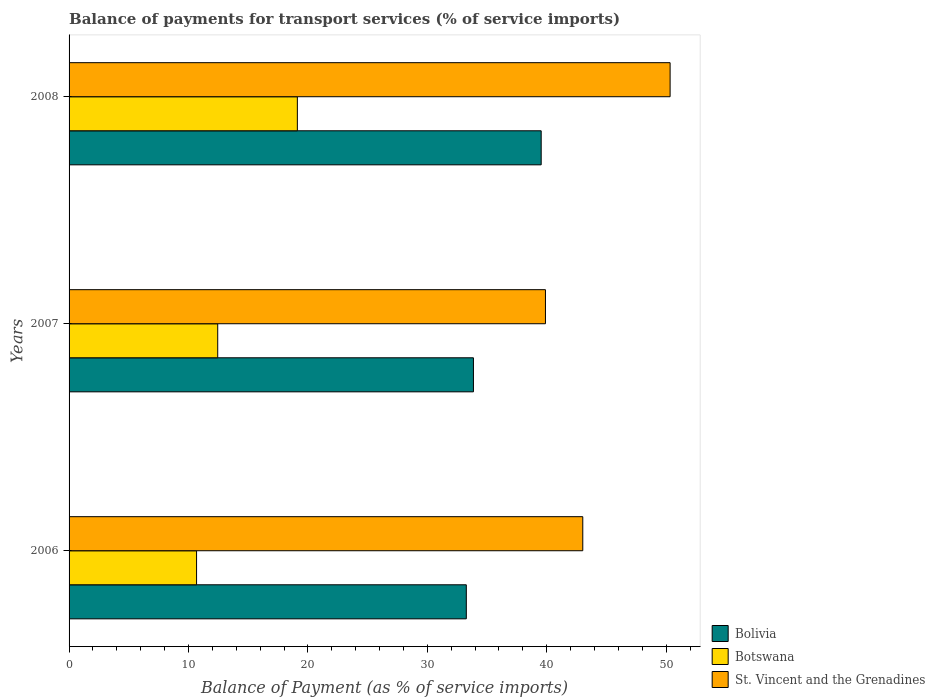How many different coloured bars are there?
Make the answer very short. 3. Are the number of bars on each tick of the Y-axis equal?
Provide a short and direct response. Yes. How many bars are there on the 3rd tick from the bottom?
Your answer should be very brief. 3. What is the label of the 3rd group of bars from the top?
Provide a succinct answer. 2006. In how many cases, is the number of bars for a given year not equal to the number of legend labels?
Ensure brevity in your answer.  0. What is the balance of payments for transport services in St. Vincent and the Grenadines in 2006?
Offer a very short reply. 43.02. Across all years, what is the maximum balance of payments for transport services in St. Vincent and the Grenadines?
Ensure brevity in your answer.  50.33. Across all years, what is the minimum balance of payments for transport services in Botswana?
Keep it short and to the point. 10.68. In which year was the balance of payments for transport services in St. Vincent and the Grenadines minimum?
Keep it short and to the point. 2007. What is the total balance of payments for transport services in Botswana in the graph?
Ensure brevity in your answer.  42.24. What is the difference between the balance of payments for transport services in Botswana in 2007 and that in 2008?
Keep it short and to the point. -6.67. What is the difference between the balance of payments for transport services in Botswana in 2006 and the balance of payments for transport services in St. Vincent and the Grenadines in 2007?
Make the answer very short. -29.21. What is the average balance of payments for transport services in Botswana per year?
Provide a succinct answer. 14.08. In the year 2008, what is the difference between the balance of payments for transport services in Bolivia and balance of payments for transport services in Botswana?
Your response must be concise. 20.42. What is the ratio of the balance of payments for transport services in Botswana in 2007 to that in 2008?
Provide a short and direct response. 0.65. Is the balance of payments for transport services in Botswana in 2007 less than that in 2008?
Offer a terse response. Yes. Is the difference between the balance of payments for transport services in Bolivia in 2006 and 2008 greater than the difference between the balance of payments for transport services in Botswana in 2006 and 2008?
Provide a short and direct response. Yes. What is the difference between the highest and the second highest balance of payments for transport services in Botswana?
Provide a short and direct response. 6.67. What is the difference between the highest and the lowest balance of payments for transport services in Botswana?
Your answer should be very brief. 8.44. Is the sum of the balance of payments for transport services in Bolivia in 2006 and 2008 greater than the maximum balance of payments for transport services in Botswana across all years?
Your answer should be compact. Yes. What does the 3rd bar from the top in 2008 represents?
Make the answer very short. Bolivia. What does the 2nd bar from the bottom in 2007 represents?
Give a very brief answer. Botswana. Is it the case that in every year, the sum of the balance of payments for transport services in Bolivia and balance of payments for transport services in Botswana is greater than the balance of payments for transport services in St. Vincent and the Grenadines?
Give a very brief answer. Yes. Are the values on the major ticks of X-axis written in scientific E-notation?
Provide a succinct answer. No. Where does the legend appear in the graph?
Give a very brief answer. Bottom right. How many legend labels are there?
Your answer should be very brief. 3. What is the title of the graph?
Give a very brief answer. Balance of payments for transport services (% of service imports). Does "Curacao" appear as one of the legend labels in the graph?
Keep it short and to the point. No. What is the label or title of the X-axis?
Make the answer very short. Balance of Payment (as % of service imports). What is the label or title of the Y-axis?
Your response must be concise. Years. What is the Balance of Payment (as % of service imports) in Bolivia in 2006?
Offer a terse response. 33.26. What is the Balance of Payment (as % of service imports) of Botswana in 2006?
Make the answer very short. 10.68. What is the Balance of Payment (as % of service imports) in St. Vincent and the Grenadines in 2006?
Your answer should be compact. 43.02. What is the Balance of Payment (as % of service imports) of Bolivia in 2007?
Your response must be concise. 33.86. What is the Balance of Payment (as % of service imports) in Botswana in 2007?
Keep it short and to the point. 12.45. What is the Balance of Payment (as % of service imports) in St. Vincent and the Grenadines in 2007?
Offer a terse response. 39.89. What is the Balance of Payment (as % of service imports) in Bolivia in 2008?
Give a very brief answer. 39.53. What is the Balance of Payment (as % of service imports) in Botswana in 2008?
Your answer should be compact. 19.12. What is the Balance of Payment (as % of service imports) in St. Vincent and the Grenadines in 2008?
Ensure brevity in your answer.  50.33. Across all years, what is the maximum Balance of Payment (as % of service imports) of Bolivia?
Ensure brevity in your answer.  39.53. Across all years, what is the maximum Balance of Payment (as % of service imports) of Botswana?
Give a very brief answer. 19.12. Across all years, what is the maximum Balance of Payment (as % of service imports) of St. Vincent and the Grenadines?
Provide a short and direct response. 50.33. Across all years, what is the minimum Balance of Payment (as % of service imports) in Bolivia?
Provide a succinct answer. 33.26. Across all years, what is the minimum Balance of Payment (as % of service imports) of Botswana?
Ensure brevity in your answer.  10.68. Across all years, what is the minimum Balance of Payment (as % of service imports) of St. Vincent and the Grenadines?
Offer a terse response. 39.89. What is the total Balance of Payment (as % of service imports) in Bolivia in the graph?
Keep it short and to the point. 106.66. What is the total Balance of Payment (as % of service imports) of Botswana in the graph?
Your answer should be very brief. 42.24. What is the total Balance of Payment (as % of service imports) of St. Vincent and the Grenadines in the graph?
Give a very brief answer. 133.24. What is the difference between the Balance of Payment (as % of service imports) in Bolivia in 2006 and that in 2007?
Your answer should be compact. -0.6. What is the difference between the Balance of Payment (as % of service imports) in Botswana in 2006 and that in 2007?
Ensure brevity in your answer.  -1.77. What is the difference between the Balance of Payment (as % of service imports) in St. Vincent and the Grenadines in 2006 and that in 2007?
Ensure brevity in your answer.  3.13. What is the difference between the Balance of Payment (as % of service imports) in Bolivia in 2006 and that in 2008?
Make the answer very short. -6.27. What is the difference between the Balance of Payment (as % of service imports) in Botswana in 2006 and that in 2008?
Offer a very short reply. -8.44. What is the difference between the Balance of Payment (as % of service imports) of St. Vincent and the Grenadines in 2006 and that in 2008?
Offer a terse response. -7.31. What is the difference between the Balance of Payment (as % of service imports) in Bolivia in 2007 and that in 2008?
Offer a very short reply. -5.67. What is the difference between the Balance of Payment (as % of service imports) in Botswana in 2007 and that in 2008?
Make the answer very short. -6.67. What is the difference between the Balance of Payment (as % of service imports) of St. Vincent and the Grenadines in 2007 and that in 2008?
Give a very brief answer. -10.44. What is the difference between the Balance of Payment (as % of service imports) in Bolivia in 2006 and the Balance of Payment (as % of service imports) in Botswana in 2007?
Give a very brief answer. 20.82. What is the difference between the Balance of Payment (as % of service imports) in Bolivia in 2006 and the Balance of Payment (as % of service imports) in St. Vincent and the Grenadines in 2007?
Provide a succinct answer. -6.63. What is the difference between the Balance of Payment (as % of service imports) in Botswana in 2006 and the Balance of Payment (as % of service imports) in St. Vincent and the Grenadines in 2007?
Provide a short and direct response. -29.21. What is the difference between the Balance of Payment (as % of service imports) in Bolivia in 2006 and the Balance of Payment (as % of service imports) in Botswana in 2008?
Keep it short and to the point. 14.15. What is the difference between the Balance of Payment (as % of service imports) in Bolivia in 2006 and the Balance of Payment (as % of service imports) in St. Vincent and the Grenadines in 2008?
Your response must be concise. -17.07. What is the difference between the Balance of Payment (as % of service imports) of Botswana in 2006 and the Balance of Payment (as % of service imports) of St. Vincent and the Grenadines in 2008?
Provide a short and direct response. -39.65. What is the difference between the Balance of Payment (as % of service imports) in Bolivia in 2007 and the Balance of Payment (as % of service imports) in Botswana in 2008?
Provide a short and direct response. 14.74. What is the difference between the Balance of Payment (as % of service imports) of Bolivia in 2007 and the Balance of Payment (as % of service imports) of St. Vincent and the Grenadines in 2008?
Give a very brief answer. -16.47. What is the difference between the Balance of Payment (as % of service imports) in Botswana in 2007 and the Balance of Payment (as % of service imports) in St. Vincent and the Grenadines in 2008?
Your response must be concise. -37.88. What is the average Balance of Payment (as % of service imports) in Bolivia per year?
Provide a succinct answer. 35.55. What is the average Balance of Payment (as % of service imports) of Botswana per year?
Your answer should be very brief. 14.08. What is the average Balance of Payment (as % of service imports) in St. Vincent and the Grenadines per year?
Offer a very short reply. 44.41. In the year 2006, what is the difference between the Balance of Payment (as % of service imports) in Bolivia and Balance of Payment (as % of service imports) in Botswana?
Offer a terse response. 22.59. In the year 2006, what is the difference between the Balance of Payment (as % of service imports) in Bolivia and Balance of Payment (as % of service imports) in St. Vincent and the Grenadines?
Offer a terse response. -9.75. In the year 2006, what is the difference between the Balance of Payment (as % of service imports) of Botswana and Balance of Payment (as % of service imports) of St. Vincent and the Grenadines?
Provide a short and direct response. -32.34. In the year 2007, what is the difference between the Balance of Payment (as % of service imports) of Bolivia and Balance of Payment (as % of service imports) of Botswana?
Offer a terse response. 21.41. In the year 2007, what is the difference between the Balance of Payment (as % of service imports) of Bolivia and Balance of Payment (as % of service imports) of St. Vincent and the Grenadines?
Ensure brevity in your answer.  -6.03. In the year 2007, what is the difference between the Balance of Payment (as % of service imports) in Botswana and Balance of Payment (as % of service imports) in St. Vincent and the Grenadines?
Offer a very short reply. -27.44. In the year 2008, what is the difference between the Balance of Payment (as % of service imports) of Bolivia and Balance of Payment (as % of service imports) of Botswana?
Your answer should be very brief. 20.42. In the year 2008, what is the difference between the Balance of Payment (as % of service imports) of Bolivia and Balance of Payment (as % of service imports) of St. Vincent and the Grenadines?
Your answer should be very brief. -10.8. In the year 2008, what is the difference between the Balance of Payment (as % of service imports) in Botswana and Balance of Payment (as % of service imports) in St. Vincent and the Grenadines?
Your answer should be very brief. -31.21. What is the ratio of the Balance of Payment (as % of service imports) in Bolivia in 2006 to that in 2007?
Your answer should be compact. 0.98. What is the ratio of the Balance of Payment (as % of service imports) in Botswana in 2006 to that in 2007?
Offer a very short reply. 0.86. What is the ratio of the Balance of Payment (as % of service imports) of St. Vincent and the Grenadines in 2006 to that in 2007?
Ensure brevity in your answer.  1.08. What is the ratio of the Balance of Payment (as % of service imports) in Bolivia in 2006 to that in 2008?
Your answer should be compact. 0.84. What is the ratio of the Balance of Payment (as % of service imports) in Botswana in 2006 to that in 2008?
Provide a succinct answer. 0.56. What is the ratio of the Balance of Payment (as % of service imports) of St. Vincent and the Grenadines in 2006 to that in 2008?
Provide a short and direct response. 0.85. What is the ratio of the Balance of Payment (as % of service imports) of Bolivia in 2007 to that in 2008?
Keep it short and to the point. 0.86. What is the ratio of the Balance of Payment (as % of service imports) of Botswana in 2007 to that in 2008?
Ensure brevity in your answer.  0.65. What is the ratio of the Balance of Payment (as % of service imports) of St. Vincent and the Grenadines in 2007 to that in 2008?
Give a very brief answer. 0.79. What is the difference between the highest and the second highest Balance of Payment (as % of service imports) in Bolivia?
Keep it short and to the point. 5.67. What is the difference between the highest and the second highest Balance of Payment (as % of service imports) in Botswana?
Make the answer very short. 6.67. What is the difference between the highest and the second highest Balance of Payment (as % of service imports) in St. Vincent and the Grenadines?
Give a very brief answer. 7.31. What is the difference between the highest and the lowest Balance of Payment (as % of service imports) of Bolivia?
Ensure brevity in your answer.  6.27. What is the difference between the highest and the lowest Balance of Payment (as % of service imports) of Botswana?
Your response must be concise. 8.44. What is the difference between the highest and the lowest Balance of Payment (as % of service imports) of St. Vincent and the Grenadines?
Offer a terse response. 10.44. 